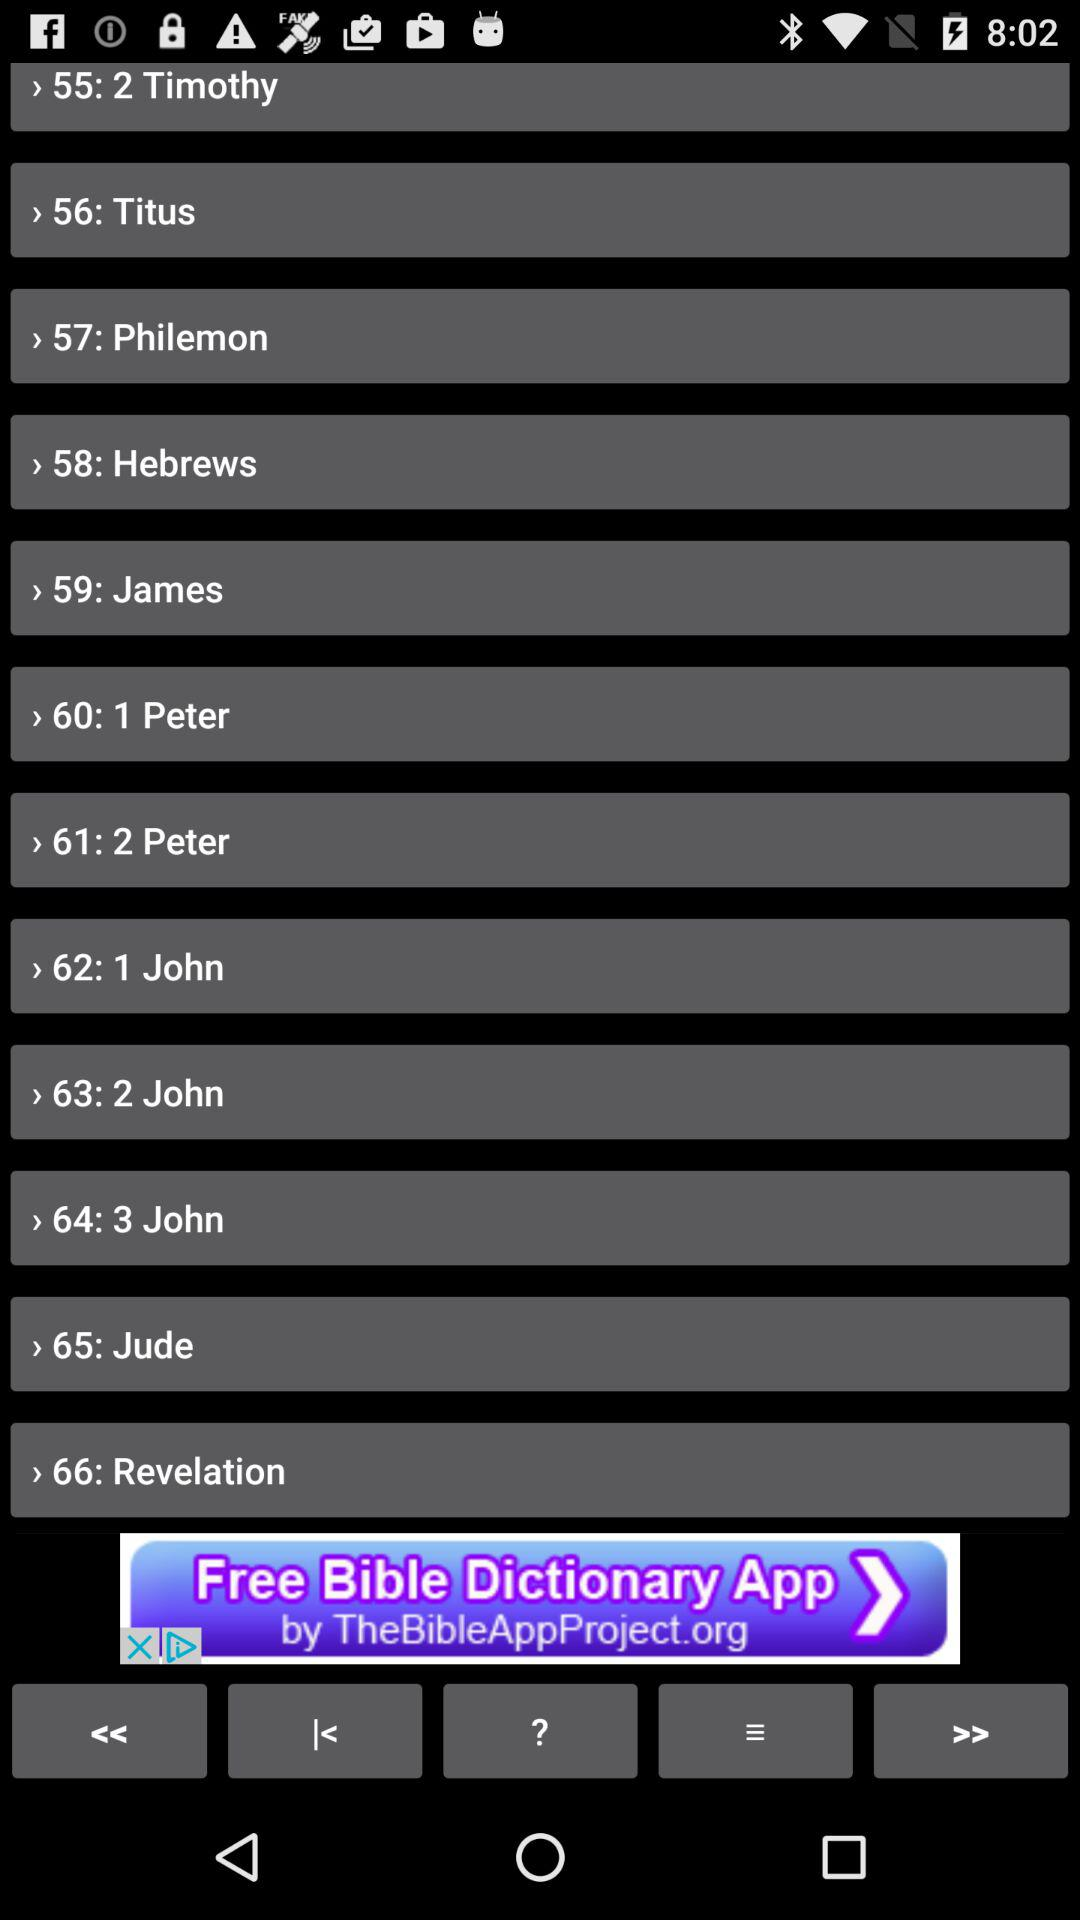Which option has the serial number 66? The option that has the serial number 66 is "Revelation". 